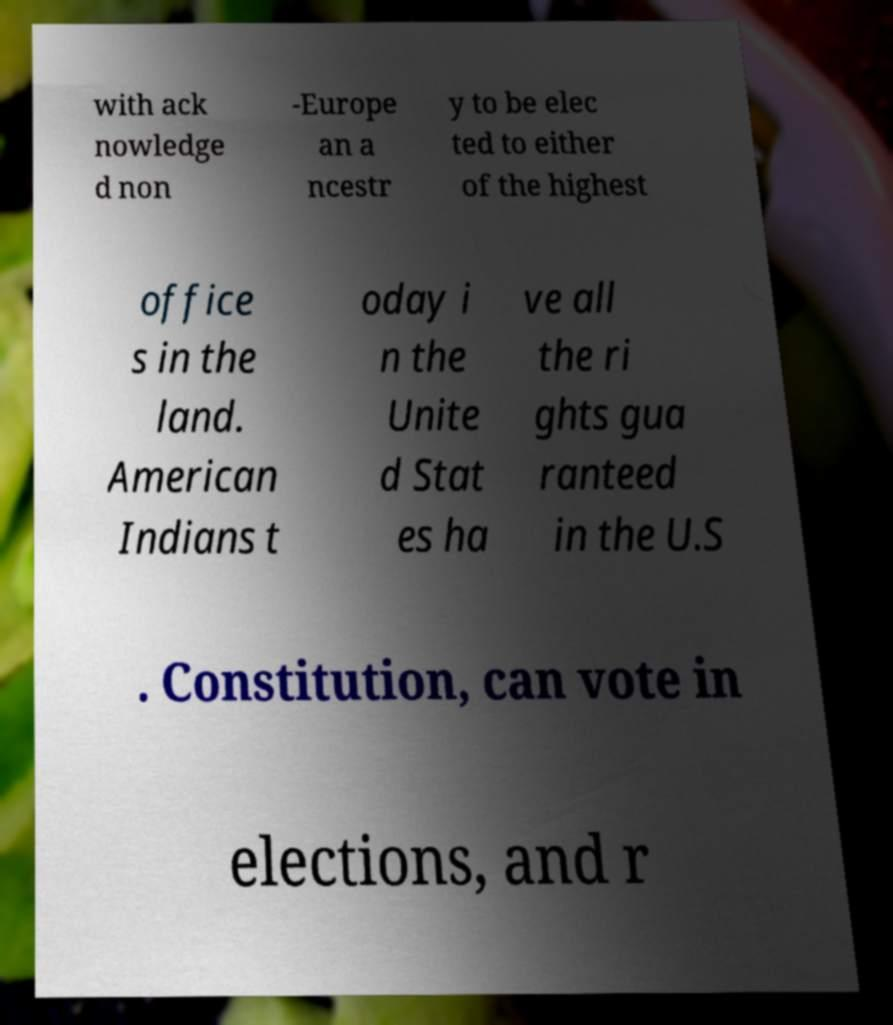Can you read and provide the text displayed in the image?This photo seems to have some interesting text. Can you extract and type it out for me? with ack nowledge d non -Europe an a ncestr y to be elec ted to either of the highest office s in the land. American Indians t oday i n the Unite d Stat es ha ve all the ri ghts gua ranteed in the U.S . Constitution, can vote in elections, and r 